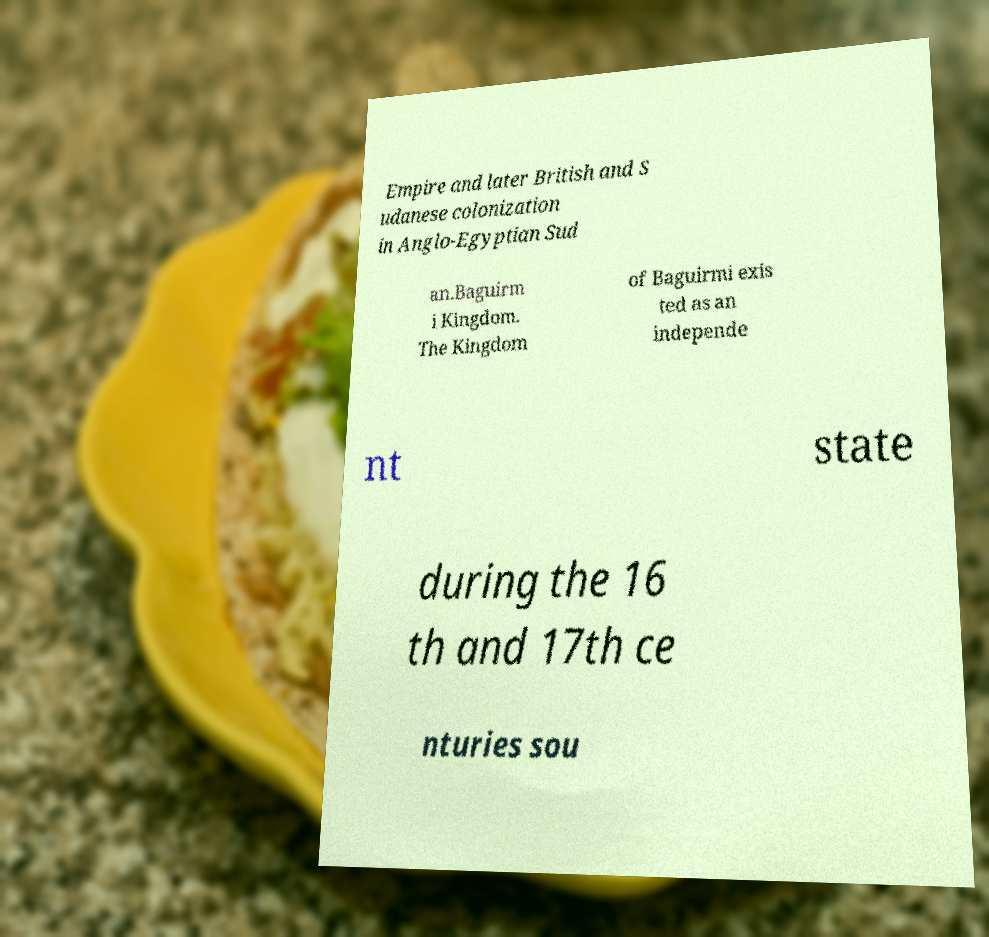Could you assist in decoding the text presented in this image and type it out clearly? Empire and later British and S udanese colonization in Anglo-Egyptian Sud an.Baguirm i Kingdom. The Kingdom of Baguirmi exis ted as an independe nt state during the 16 th and 17th ce nturies sou 